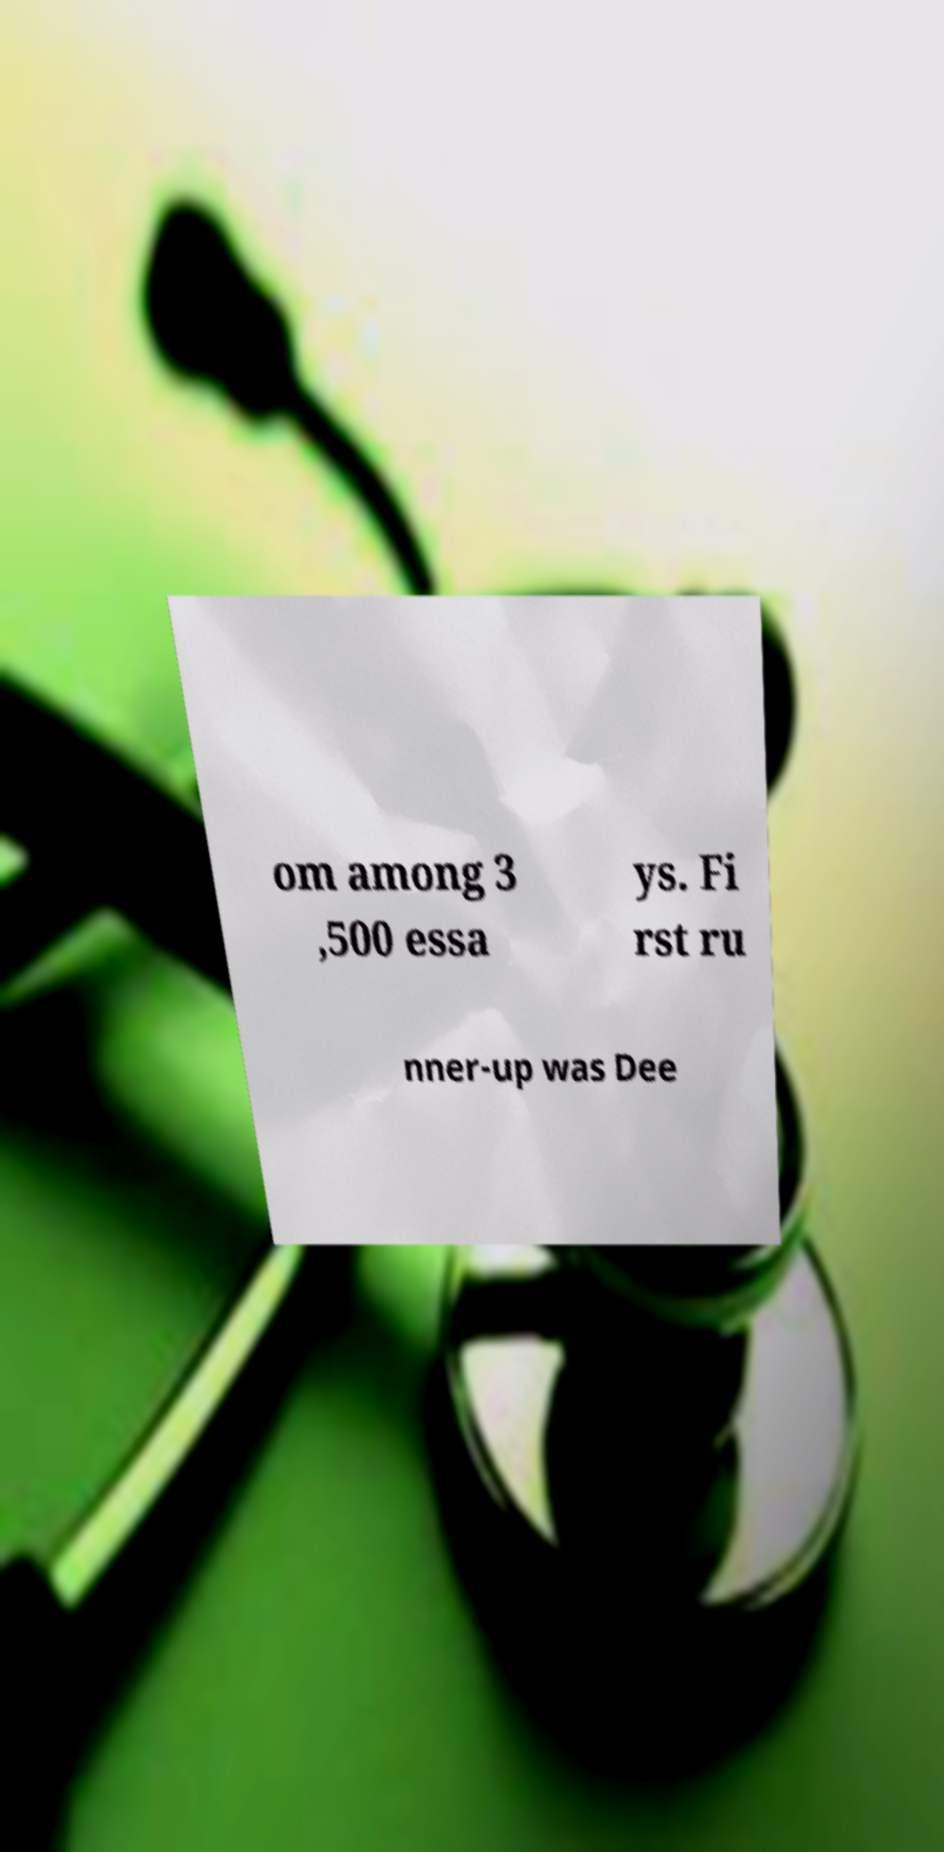Could you extract and type out the text from this image? om among 3 ,500 essa ys. Fi rst ru nner-up was Dee 